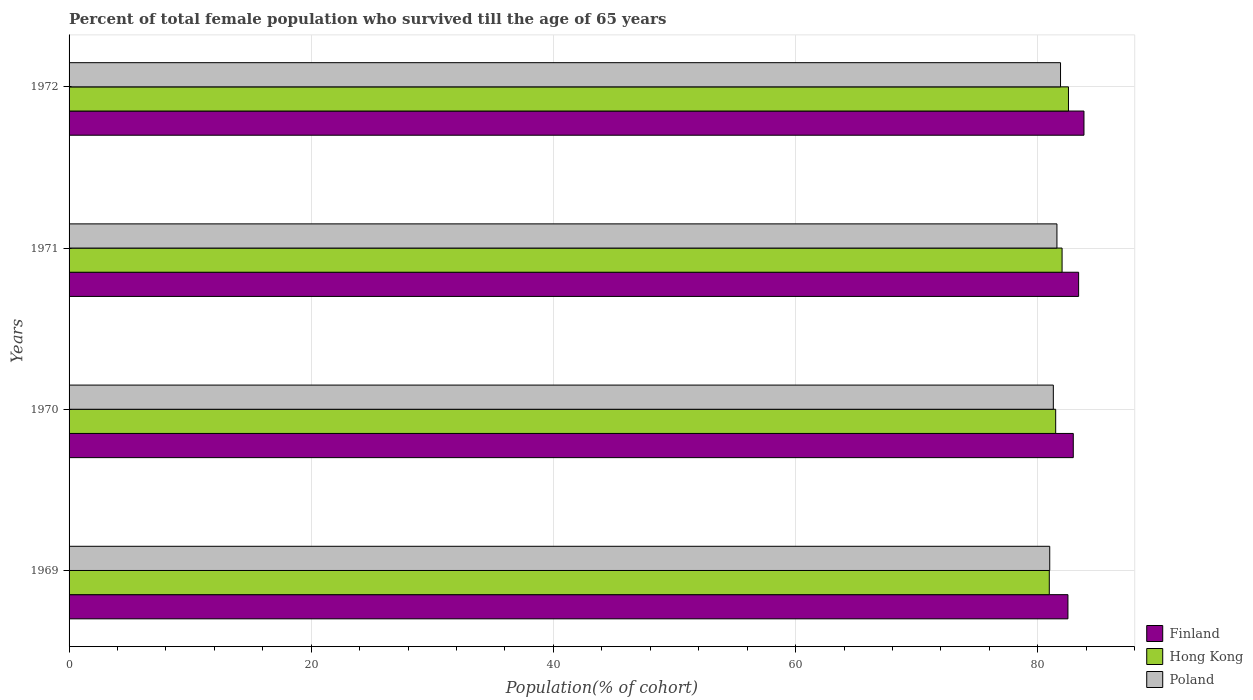How many different coloured bars are there?
Your answer should be very brief. 3. How many groups of bars are there?
Offer a very short reply. 4. How many bars are there on the 1st tick from the top?
Ensure brevity in your answer.  3. How many bars are there on the 3rd tick from the bottom?
Your answer should be very brief. 3. What is the label of the 1st group of bars from the top?
Give a very brief answer. 1972. What is the percentage of total female population who survived till the age of 65 years in Poland in 1972?
Make the answer very short. 81.88. Across all years, what is the maximum percentage of total female population who survived till the age of 65 years in Poland?
Make the answer very short. 81.88. Across all years, what is the minimum percentage of total female population who survived till the age of 65 years in Poland?
Provide a succinct answer. 80.99. In which year was the percentage of total female population who survived till the age of 65 years in Poland maximum?
Ensure brevity in your answer.  1972. In which year was the percentage of total female population who survived till the age of 65 years in Poland minimum?
Offer a very short reply. 1969. What is the total percentage of total female population who survived till the age of 65 years in Poland in the graph?
Ensure brevity in your answer.  325.74. What is the difference between the percentage of total female population who survived till the age of 65 years in Poland in 1969 and that in 1970?
Give a very brief answer. -0.3. What is the difference between the percentage of total female population who survived till the age of 65 years in Poland in 1969 and the percentage of total female population who survived till the age of 65 years in Hong Kong in 1972?
Your answer should be very brief. -1.55. What is the average percentage of total female population who survived till the age of 65 years in Poland per year?
Keep it short and to the point. 81.43. In the year 1969, what is the difference between the percentage of total female population who survived till the age of 65 years in Hong Kong and percentage of total female population who survived till the age of 65 years in Poland?
Keep it short and to the point. -0.04. What is the ratio of the percentage of total female population who survived till the age of 65 years in Hong Kong in 1969 to that in 1972?
Your answer should be compact. 0.98. What is the difference between the highest and the second highest percentage of total female population who survived till the age of 65 years in Poland?
Your answer should be compact. 0.3. What is the difference between the highest and the lowest percentage of total female population who survived till the age of 65 years in Hong Kong?
Offer a terse response. 1.58. In how many years, is the percentage of total female population who survived till the age of 65 years in Finland greater than the average percentage of total female population who survived till the age of 65 years in Finland taken over all years?
Provide a short and direct response. 2. Is the sum of the percentage of total female population who survived till the age of 65 years in Finland in 1969 and 1972 greater than the maximum percentage of total female population who survived till the age of 65 years in Poland across all years?
Make the answer very short. Yes. What does the 3rd bar from the top in 1969 represents?
Your answer should be very brief. Finland. What does the 2nd bar from the bottom in 1969 represents?
Your response must be concise. Hong Kong. Is it the case that in every year, the sum of the percentage of total female population who survived till the age of 65 years in Poland and percentage of total female population who survived till the age of 65 years in Finland is greater than the percentage of total female population who survived till the age of 65 years in Hong Kong?
Provide a short and direct response. Yes. How many bars are there?
Your response must be concise. 12. Are all the bars in the graph horizontal?
Ensure brevity in your answer.  Yes. What is the difference between two consecutive major ticks on the X-axis?
Provide a succinct answer. 20. Are the values on the major ticks of X-axis written in scientific E-notation?
Keep it short and to the point. No. Where does the legend appear in the graph?
Give a very brief answer. Bottom right. How many legend labels are there?
Your answer should be very brief. 3. How are the legend labels stacked?
Your answer should be very brief. Vertical. What is the title of the graph?
Keep it short and to the point. Percent of total female population who survived till the age of 65 years. What is the label or title of the X-axis?
Provide a succinct answer. Population(% of cohort). What is the label or title of the Y-axis?
Make the answer very short. Years. What is the Population(% of cohort) of Finland in 1969?
Ensure brevity in your answer.  82.49. What is the Population(% of cohort) of Hong Kong in 1969?
Offer a terse response. 80.95. What is the Population(% of cohort) in Poland in 1969?
Your answer should be compact. 80.99. What is the Population(% of cohort) in Finland in 1970?
Give a very brief answer. 82.93. What is the Population(% of cohort) in Hong Kong in 1970?
Your response must be concise. 81.48. What is the Population(% of cohort) in Poland in 1970?
Provide a short and direct response. 81.29. What is the Population(% of cohort) of Finland in 1971?
Keep it short and to the point. 83.37. What is the Population(% of cohort) of Hong Kong in 1971?
Provide a short and direct response. 82.01. What is the Population(% of cohort) of Poland in 1971?
Offer a terse response. 81.58. What is the Population(% of cohort) of Finland in 1972?
Offer a very short reply. 83.82. What is the Population(% of cohort) in Hong Kong in 1972?
Your answer should be compact. 82.54. What is the Population(% of cohort) in Poland in 1972?
Provide a succinct answer. 81.88. Across all years, what is the maximum Population(% of cohort) in Finland?
Keep it short and to the point. 83.82. Across all years, what is the maximum Population(% of cohort) of Hong Kong?
Your answer should be very brief. 82.54. Across all years, what is the maximum Population(% of cohort) in Poland?
Your answer should be compact. 81.88. Across all years, what is the minimum Population(% of cohort) in Finland?
Keep it short and to the point. 82.49. Across all years, what is the minimum Population(% of cohort) of Hong Kong?
Your answer should be compact. 80.95. Across all years, what is the minimum Population(% of cohort) of Poland?
Your answer should be very brief. 80.99. What is the total Population(% of cohort) in Finland in the graph?
Keep it short and to the point. 332.62. What is the total Population(% of cohort) in Hong Kong in the graph?
Give a very brief answer. 326.98. What is the total Population(% of cohort) of Poland in the graph?
Your answer should be compact. 325.74. What is the difference between the Population(% of cohort) in Finland in 1969 and that in 1970?
Provide a succinct answer. -0.44. What is the difference between the Population(% of cohort) in Hong Kong in 1969 and that in 1970?
Keep it short and to the point. -0.53. What is the difference between the Population(% of cohort) of Poland in 1969 and that in 1970?
Ensure brevity in your answer.  -0.3. What is the difference between the Population(% of cohort) of Finland in 1969 and that in 1971?
Your answer should be compact. -0.88. What is the difference between the Population(% of cohort) of Hong Kong in 1969 and that in 1971?
Your response must be concise. -1.06. What is the difference between the Population(% of cohort) in Poland in 1969 and that in 1971?
Provide a short and direct response. -0.59. What is the difference between the Population(% of cohort) of Finland in 1969 and that in 1972?
Ensure brevity in your answer.  -1.32. What is the difference between the Population(% of cohort) in Hong Kong in 1969 and that in 1972?
Your answer should be compact. -1.58. What is the difference between the Population(% of cohort) of Poland in 1969 and that in 1972?
Your response must be concise. -0.89. What is the difference between the Population(% of cohort) in Finland in 1970 and that in 1971?
Your answer should be compact. -0.44. What is the difference between the Population(% of cohort) in Hong Kong in 1970 and that in 1971?
Your answer should be very brief. -0.53. What is the difference between the Population(% of cohort) of Poland in 1970 and that in 1971?
Your answer should be very brief. -0.3. What is the difference between the Population(% of cohort) in Finland in 1970 and that in 1972?
Your answer should be compact. -0.88. What is the difference between the Population(% of cohort) of Hong Kong in 1970 and that in 1972?
Your answer should be very brief. -1.06. What is the difference between the Population(% of cohort) in Poland in 1970 and that in 1972?
Your answer should be very brief. -0.59. What is the difference between the Population(% of cohort) of Finland in 1971 and that in 1972?
Your answer should be very brief. -0.44. What is the difference between the Population(% of cohort) of Hong Kong in 1971 and that in 1972?
Your answer should be compact. -0.53. What is the difference between the Population(% of cohort) of Poland in 1971 and that in 1972?
Make the answer very short. -0.3. What is the difference between the Population(% of cohort) of Finland in 1969 and the Population(% of cohort) of Hong Kong in 1970?
Offer a very short reply. 1.01. What is the difference between the Population(% of cohort) of Finland in 1969 and the Population(% of cohort) of Poland in 1970?
Keep it short and to the point. 1.21. What is the difference between the Population(% of cohort) of Hong Kong in 1969 and the Population(% of cohort) of Poland in 1970?
Give a very brief answer. -0.33. What is the difference between the Population(% of cohort) of Finland in 1969 and the Population(% of cohort) of Hong Kong in 1971?
Provide a short and direct response. 0.48. What is the difference between the Population(% of cohort) in Finland in 1969 and the Population(% of cohort) in Poland in 1971?
Your answer should be very brief. 0.91. What is the difference between the Population(% of cohort) in Hong Kong in 1969 and the Population(% of cohort) in Poland in 1971?
Make the answer very short. -0.63. What is the difference between the Population(% of cohort) in Finland in 1969 and the Population(% of cohort) in Hong Kong in 1972?
Make the answer very short. -0.04. What is the difference between the Population(% of cohort) in Finland in 1969 and the Population(% of cohort) in Poland in 1972?
Offer a terse response. 0.61. What is the difference between the Population(% of cohort) of Hong Kong in 1969 and the Population(% of cohort) of Poland in 1972?
Provide a short and direct response. -0.93. What is the difference between the Population(% of cohort) in Finland in 1970 and the Population(% of cohort) in Hong Kong in 1971?
Keep it short and to the point. 0.92. What is the difference between the Population(% of cohort) of Finland in 1970 and the Population(% of cohort) of Poland in 1971?
Ensure brevity in your answer.  1.35. What is the difference between the Population(% of cohort) in Hong Kong in 1970 and the Population(% of cohort) in Poland in 1971?
Offer a terse response. -0.1. What is the difference between the Population(% of cohort) of Finland in 1970 and the Population(% of cohort) of Hong Kong in 1972?
Your answer should be very brief. 0.4. What is the difference between the Population(% of cohort) of Finland in 1970 and the Population(% of cohort) of Poland in 1972?
Offer a terse response. 1.05. What is the difference between the Population(% of cohort) in Hong Kong in 1970 and the Population(% of cohort) in Poland in 1972?
Your answer should be very brief. -0.4. What is the difference between the Population(% of cohort) of Finland in 1971 and the Population(% of cohort) of Hong Kong in 1972?
Your answer should be compact. 0.84. What is the difference between the Population(% of cohort) of Finland in 1971 and the Population(% of cohort) of Poland in 1972?
Provide a short and direct response. 1.49. What is the difference between the Population(% of cohort) of Hong Kong in 1971 and the Population(% of cohort) of Poland in 1972?
Your answer should be very brief. 0.13. What is the average Population(% of cohort) of Finland per year?
Your answer should be very brief. 83.15. What is the average Population(% of cohort) of Hong Kong per year?
Your answer should be very brief. 81.74. What is the average Population(% of cohort) in Poland per year?
Ensure brevity in your answer.  81.43. In the year 1969, what is the difference between the Population(% of cohort) of Finland and Population(% of cohort) of Hong Kong?
Provide a short and direct response. 1.54. In the year 1969, what is the difference between the Population(% of cohort) in Finland and Population(% of cohort) in Poland?
Your response must be concise. 1.5. In the year 1969, what is the difference between the Population(% of cohort) in Hong Kong and Population(% of cohort) in Poland?
Give a very brief answer. -0.04. In the year 1970, what is the difference between the Population(% of cohort) of Finland and Population(% of cohort) of Hong Kong?
Offer a very short reply. 1.45. In the year 1970, what is the difference between the Population(% of cohort) of Finland and Population(% of cohort) of Poland?
Your response must be concise. 1.65. In the year 1970, what is the difference between the Population(% of cohort) of Hong Kong and Population(% of cohort) of Poland?
Make the answer very short. 0.19. In the year 1971, what is the difference between the Population(% of cohort) in Finland and Population(% of cohort) in Hong Kong?
Your response must be concise. 1.37. In the year 1971, what is the difference between the Population(% of cohort) in Finland and Population(% of cohort) in Poland?
Your answer should be compact. 1.79. In the year 1971, what is the difference between the Population(% of cohort) of Hong Kong and Population(% of cohort) of Poland?
Provide a short and direct response. 0.43. In the year 1972, what is the difference between the Population(% of cohort) of Finland and Population(% of cohort) of Hong Kong?
Offer a terse response. 1.28. In the year 1972, what is the difference between the Population(% of cohort) of Finland and Population(% of cohort) of Poland?
Offer a terse response. 1.94. In the year 1972, what is the difference between the Population(% of cohort) in Hong Kong and Population(% of cohort) in Poland?
Ensure brevity in your answer.  0.66. What is the ratio of the Population(% of cohort) in Finland in 1969 to that in 1970?
Make the answer very short. 0.99. What is the ratio of the Population(% of cohort) of Hong Kong in 1969 to that in 1970?
Provide a succinct answer. 0.99. What is the ratio of the Population(% of cohort) in Poland in 1969 to that in 1970?
Make the answer very short. 1. What is the ratio of the Population(% of cohort) in Finland in 1969 to that in 1971?
Provide a short and direct response. 0.99. What is the ratio of the Population(% of cohort) of Hong Kong in 1969 to that in 1971?
Provide a short and direct response. 0.99. What is the ratio of the Population(% of cohort) in Poland in 1969 to that in 1971?
Keep it short and to the point. 0.99. What is the ratio of the Population(% of cohort) in Finland in 1969 to that in 1972?
Ensure brevity in your answer.  0.98. What is the ratio of the Population(% of cohort) of Hong Kong in 1969 to that in 1972?
Provide a succinct answer. 0.98. What is the ratio of the Population(% of cohort) in Poland in 1970 to that in 1971?
Make the answer very short. 1. What is the ratio of the Population(% of cohort) in Finland in 1970 to that in 1972?
Give a very brief answer. 0.99. What is the ratio of the Population(% of cohort) of Hong Kong in 1970 to that in 1972?
Ensure brevity in your answer.  0.99. What is the ratio of the Population(% of cohort) of Poland in 1970 to that in 1972?
Your answer should be compact. 0.99. What is the ratio of the Population(% of cohort) of Poland in 1971 to that in 1972?
Give a very brief answer. 1. What is the difference between the highest and the second highest Population(% of cohort) in Finland?
Ensure brevity in your answer.  0.44. What is the difference between the highest and the second highest Population(% of cohort) in Hong Kong?
Your response must be concise. 0.53. What is the difference between the highest and the second highest Population(% of cohort) of Poland?
Offer a very short reply. 0.3. What is the difference between the highest and the lowest Population(% of cohort) of Finland?
Your response must be concise. 1.32. What is the difference between the highest and the lowest Population(% of cohort) in Hong Kong?
Make the answer very short. 1.58. What is the difference between the highest and the lowest Population(% of cohort) of Poland?
Keep it short and to the point. 0.89. 